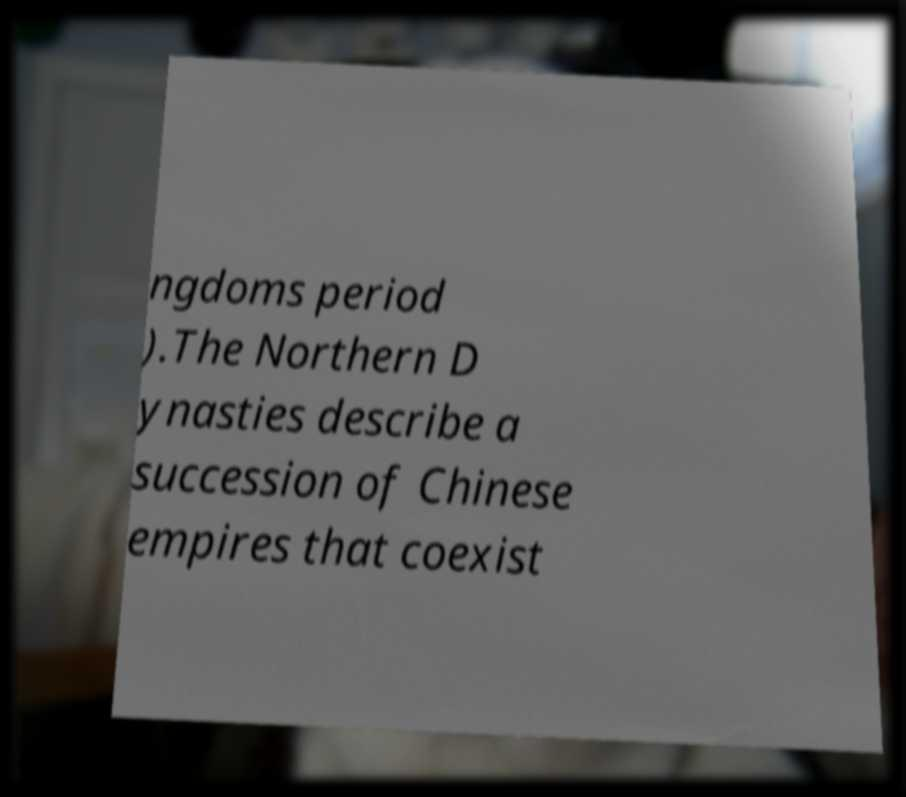Can you read and provide the text displayed in the image?This photo seems to have some interesting text. Can you extract and type it out for me? ngdoms period ).The Northern D ynasties describe a succession of Chinese empires that coexist 